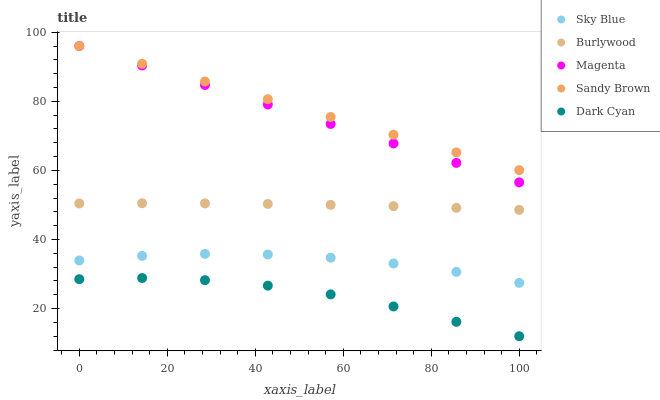Does Dark Cyan have the minimum area under the curve?
Answer yes or no. Yes. Does Sandy Brown have the maximum area under the curve?
Answer yes or no. Yes. Does Sky Blue have the minimum area under the curve?
Answer yes or no. No. Does Sky Blue have the maximum area under the curve?
Answer yes or no. No. Is Sandy Brown the smoothest?
Answer yes or no. Yes. Is Dark Cyan the roughest?
Answer yes or no. Yes. Is Sky Blue the smoothest?
Answer yes or no. No. Is Sky Blue the roughest?
Answer yes or no. No. Does Dark Cyan have the lowest value?
Answer yes or no. Yes. Does Sky Blue have the lowest value?
Answer yes or no. No. Does Sandy Brown have the highest value?
Answer yes or no. Yes. Does Sky Blue have the highest value?
Answer yes or no. No. Is Sky Blue less than Sandy Brown?
Answer yes or no. Yes. Is Sandy Brown greater than Sky Blue?
Answer yes or no. Yes. Does Magenta intersect Sandy Brown?
Answer yes or no. Yes. Is Magenta less than Sandy Brown?
Answer yes or no. No. Is Magenta greater than Sandy Brown?
Answer yes or no. No. Does Sky Blue intersect Sandy Brown?
Answer yes or no. No. 